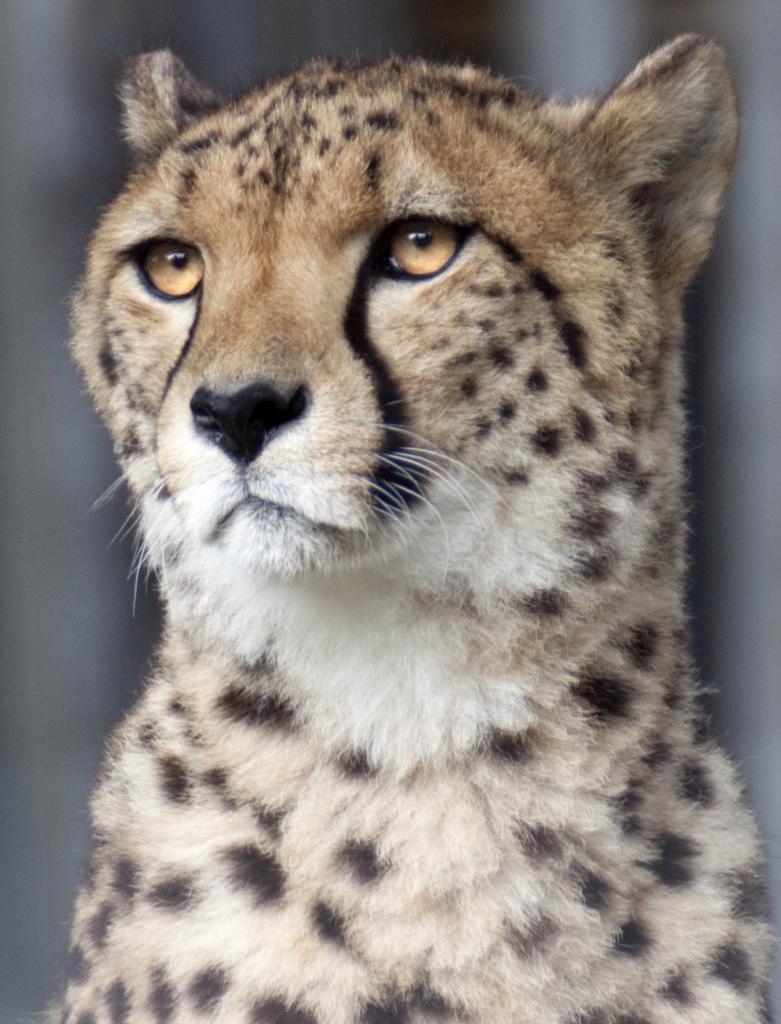Please provide a concise description of this image. In this image I can see a leopard in the front. I can see colour of this leopard is white, cream and black. I can also see this image is blurry in the background. 